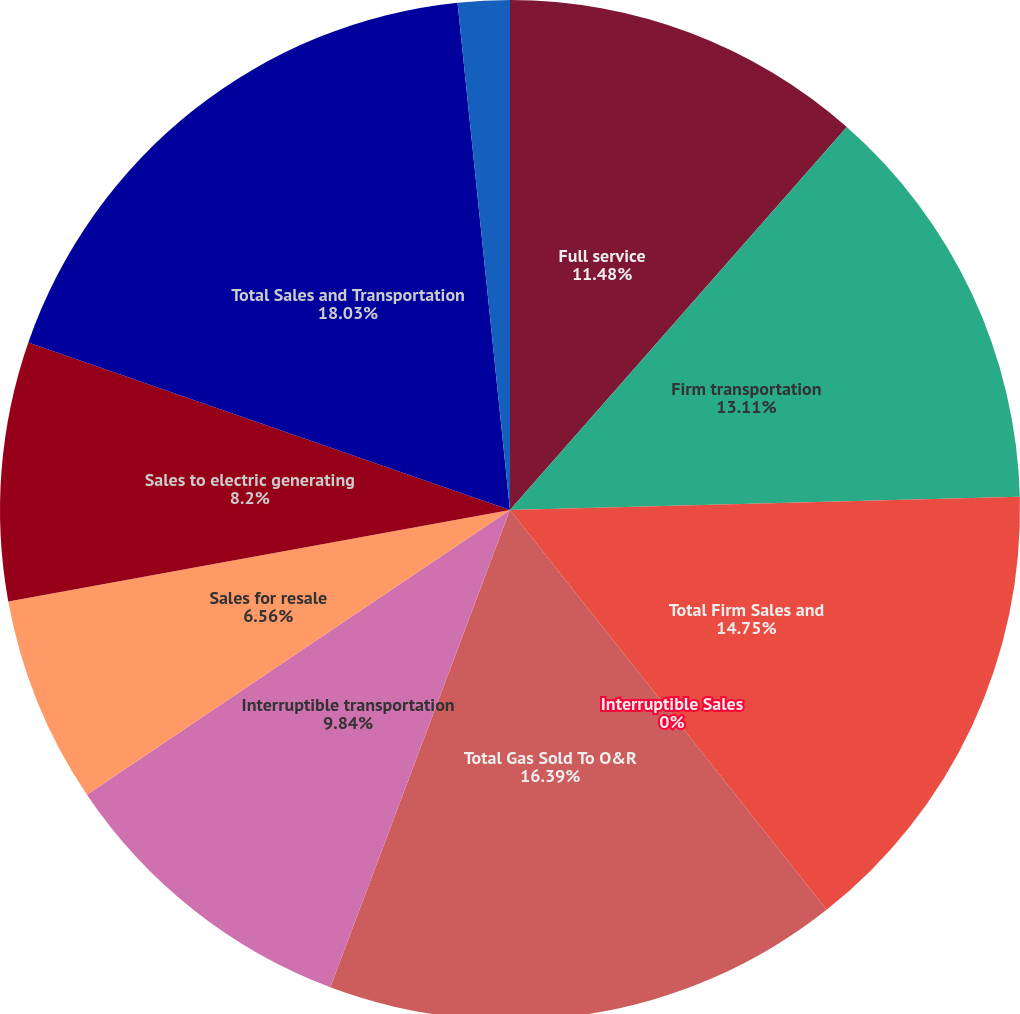Convert chart to OTSL. <chart><loc_0><loc_0><loc_500><loc_500><pie_chart><fcel>Full service<fcel>Firm transportation<fcel>Total Firm Sales and<fcel>Interruptible Sales<fcel>Total Gas Sold To O&R<fcel>Interruptible transportation<fcel>Sales for resale<fcel>Sales to electric generating<fcel>Total Sales and Transportation<fcel>Other operating revenues<nl><fcel>11.48%<fcel>13.11%<fcel>14.75%<fcel>0.0%<fcel>16.39%<fcel>9.84%<fcel>6.56%<fcel>8.2%<fcel>18.03%<fcel>1.64%<nl></chart> 